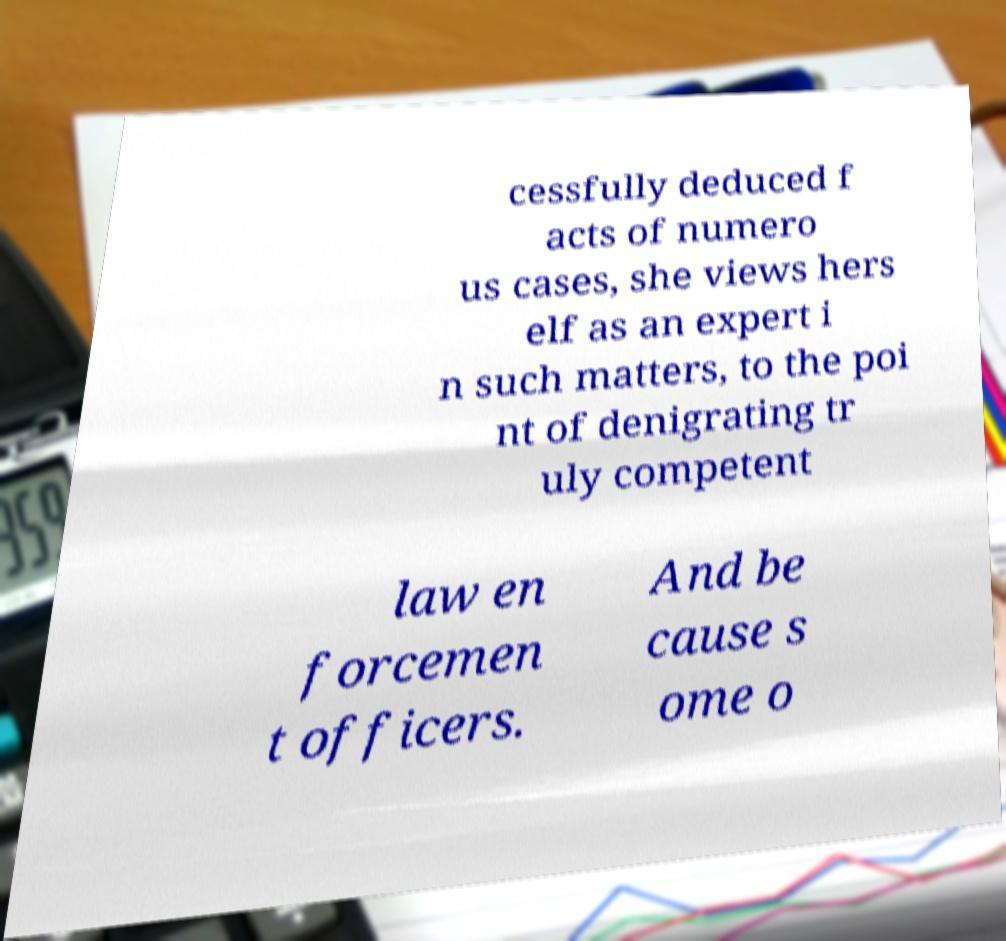Can you read and provide the text displayed in the image?This photo seems to have some interesting text. Can you extract and type it out for me? cessfully deduced f acts of numero us cases, she views hers elf as an expert i n such matters, to the poi nt of denigrating tr uly competent law en forcemen t officers. And be cause s ome o 